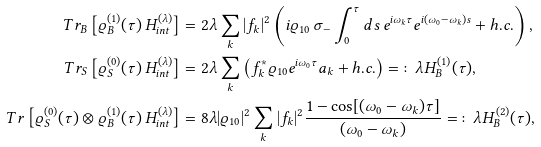Convert formula to latex. <formula><loc_0><loc_0><loc_500><loc_500>T r _ { B } \left [ \varrho ^ { ( 1 ) } _ { B } ( \tau ) \, H _ { i n t } ^ { ( \lambda ) } \right ] & = 2 \lambda \sum _ { k } | f _ { k } | ^ { 2 } \left ( i \varrho _ { 1 0 } \, \sigma _ { - } \int _ { 0 } ^ { \tau } d s \, e ^ { i \omega _ { k } \tau } e ^ { i ( \omega _ { 0 } - \omega _ { k } ) s } + h . c . \right ) , \\ T r _ { S } \left [ \varrho ^ { ( 0 ) } _ { S } ( \tau ) \, H _ { i n t } ^ { ( \lambda ) } \right ] & = 2 \lambda \sum _ { k } \left ( f ^ { * } _ { k } \varrho _ { 1 0 } e ^ { i \omega _ { 0 } \tau } a _ { k } + h . c . \right ) = \colon \lambda H _ { B } ^ { ( 1 ) } ( \tau ) , \\ T r \left [ \varrho _ { S } ^ { ( 0 ) } ( \tau ) \otimes \varrho ^ { ( 1 ) } _ { B } ( \tau ) \, H _ { i n t } ^ { ( \lambda ) } \right ] & = 8 \lambda | \varrho _ { 1 0 } | ^ { 2 } \sum _ { k } | f _ { k } | ^ { 2 } \frac { 1 - \cos [ ( \omega _ { 0 } - \omega _ { k } ) \tau ] } { ( \omega _ { 0 } - \omega _ { k } ) } = \colon \lambda H _ { B } ^ { ( 2 ) } ( \tau ) ,</formula> 